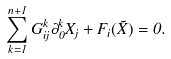Convert formula to latex. <formula><loc_0><loc_0><loc_500><loc_500>\sum _ { k = 1 } ^ { n + 1 } G _ { i j } ^ { k } \partial _ { 0 } ^ { k } X _ { j } + F _ { i } ( \vec { X } ) = 0 .</formula> 